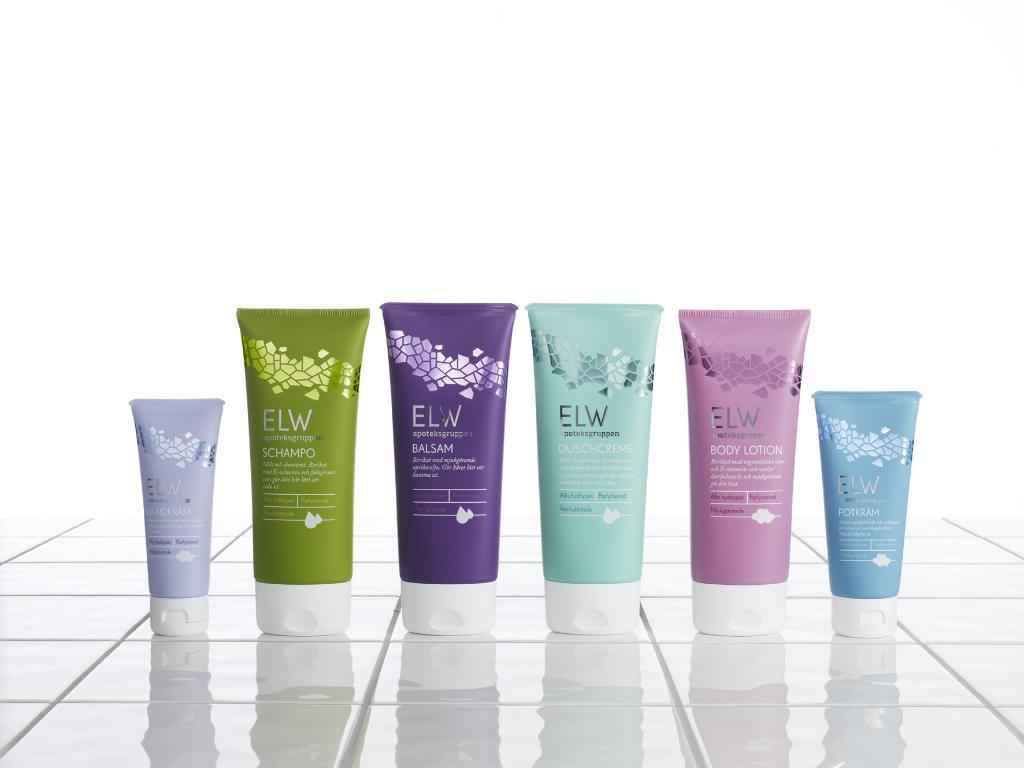In one or two sentences, can you explain what this image depicts? In this picture we can see different colors of tubes, at the bottom there are some titles, we can see a white color background. 